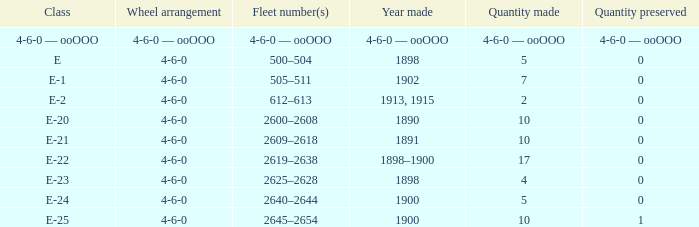Could you help me parse every detail presented in this table? {'header': ['Class', 'Wheel arrangement', 'Fleet number(s)', 'Year made', 'Quantity made', 'Quantity preserved'], 'rows': [['4-6-0 — ooOOO', '4-6-0 — ooOOO', '4-6-0 — ooOOO', '4-6-0 — ooOOO', '4-6-0 — ooOOO', '4-6-0 — ooOOO'], ['E', '4-6-0', '500–504', '1898', '5', '0'], ['E-1', '4-6-0', '505–511', '1902', '7', '0'], ['E-2', '4-6-0', '612–613', '1913, 1915', '2', '0'], ['E-20', '4-6-0', '2600–2608', '1890', '10', '0'], ['E-21', '4-6-0', '2609–2618', '1891', '10', '0'], ['E-22', '4-6-0', '2619–2638', '1898–1900', '17', '0'], ['E-23', '4-6-0', '2625–2628', '1898', '4', '0'], ['E-24', '4-6-0', '2640–2644', '1900', '5', '0'], ['E-25', '4-6-0', '2645–2654', '1900', '10', '1']]} What is the fleet number with a 4-6-0 wheel arrangement made in 1890? 2600–2608. 